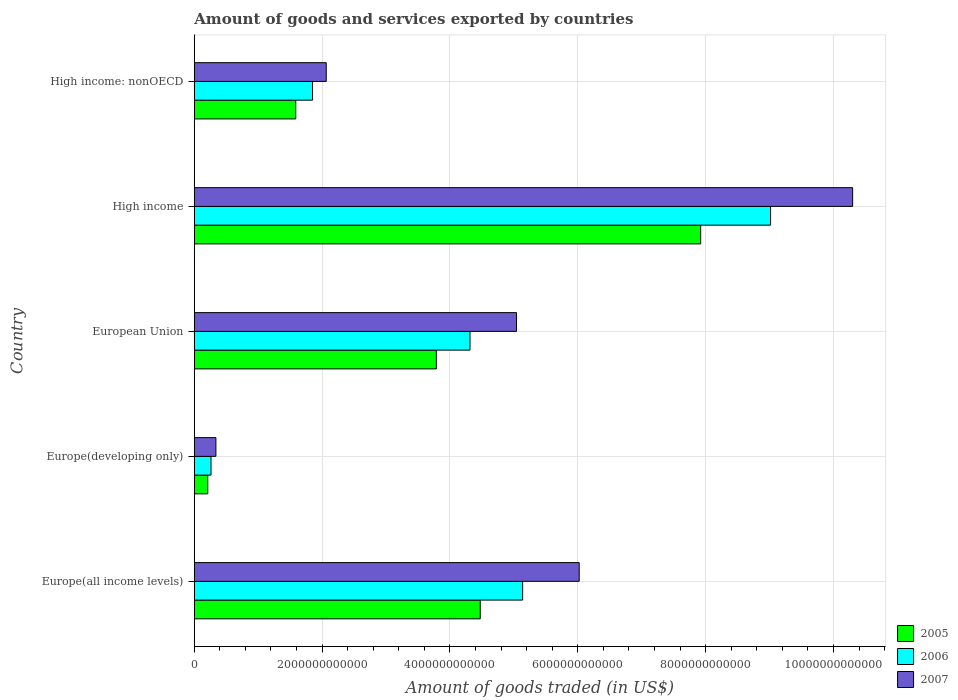How many different coloured bars are there?
Provide a succinct answer. 3. Are the number of bars per tick equal to the number of legend labels?
Give a very brief answer. Yes. Are the number of bars on each tick of the Y-axis equal?
Your answer should be compact. Yes. How many bars are there on the 4th tick from the top?
Make the answer very short. 3. How many bars are there on the 4th tick from the bottom?
Your response must be concise. 3. What is the label of the 4th group of bars from the top?
Keep it short and to the point. Europe(developing only). In how many cases, is the number of bars for a given country not equal to the number of legend labels?
Provide a succinct answer. 0. What is the total amount of goods and services exported in 2006 in High income?
Provide a succinct answer. 9.02e+12. Across all countries, what is the maximum total amount of goods and services exported in 2006?
Your answer should be very brief. 9.02e+12. Across all countries, what is the minimum total amount of goods and services exported in 2005?
Your answer should be very brief. 2.11e+11. In which country was the total amount of goods and services exported in 2006 minimum?
Make the answer very short. Europe(developing only). What is the total total amount of goods and services exported in 2007 in the graph?
Make the answer very short. 2.38e+13. What is the difference between the total amount of goods and services exported in 2006 in Europe(developing only) and that in High income: nonOECD?
Provide a short and direct response. -1.59e+12. What is the difference between the total amount of goods and services exported in 2007 in Europe(developing only) and the total amount of goods and services exported in 2006 in European Union?
Your answer should be very brief. -3.98e+12. What is the average total amount of goods and services exported in 2006 per country?
Your answer should be very brief. 4.12e+12. What is the difference between the total amount of goods and services exported in 2007 and total amount of goods and services exported in 2005 in Europe(developing only)?
Offer a very short reply. 1.28e+11. In how many countries, is the total amount of goods and services exported in 2007 greater than 8800000000000 US$?
Ensure brevity in your answer.  1. What is the ratio of the total amount of goods and services exported in 2005 in Europe(developing only) to that in High income?
Offer a terse response. 0.03. Is the total amount of goods and services exported in 2005 in Europe(all income levels) less than that in High income?
Your response must be concise. Yes. What is the difference between the highest and the second highest total amount of goods and services exported in 2007?
Give a very brief answer. 4.28e+12. What is the difference between the highest and the lowest total amount of goods and services exported in 2005?
Your answer should be compact. 7.71e+12. Is the sum of the total amount of goods and services exported in 2005 in European Union and High income greater than the maximum total amount of goods and services exported in 2006 across all countries?
Your answer should be very brief. Yes. What does the 2nd bar from the top in European Union represents?
Keep it short and to the point. 2006. What does the 2nd bar from the bottom in European Union represents?
Ensure brevity in your answer.  2006. How many countries are there in the graph?
Your answer should be very brief. 5. What is the difference between two consecutive major ticks on the X-axis?
Offer a very short reply. 2.00e+12. Are the values on the major ticks of X-axis written in scientific E-notation?
Your answer should be very brief. No. What is the title of the graph?
Give a very brief answer. Amount of goods and services exported by countries. What is the label or title of the X-axis?
Provide a short and direct response. Amount of goods traded (in US$). What is the label or title of the Y-axis?
Make the answer very short. Country. What is the Amount of goods traded (in US$) in 2005 in Europe(all income levels)?
Your response must be concise. 4.47e+12. What is the Amount of goods traded (in US$) of 2006 in Europe(all income levels)?
Your answer should be compact. 5.14e+12. What is the Amount of goods traded (in US$) of 2007 in Europe(all income levels)?
Your response must be concise. 6.02e+12. What is the Amount of goods traded (in US$) of 2005 in Europe(developing only)?
Ensure brevity in your answer.  2.11e+11. What is the Amount of goods traded (in US$) of 2006 in Europe(developing only)?
Keep it short and to the point. 2.62e+11. What is the Amount of goods traded (in US$) in 2007 in Europe(developing only)?
Your response must be concise. 3.39e+11. What is the Amount of goods traded (in US$) in 2005 in European Union?
Offer a terse response. 3.79e+12. What is the Amount of goods traded (in US$) in 2006 in European Union?
Provide a succinct answer. 4.31e+12. What is the Amount of goods traded (in US$) of 2007 in European Union?
Keep it short and to the point. 5.04e+12. What is the Amount of goods traded (in US$) of 2005 in High income?
Keep it short and to the point. 7.92e+12. What is the Amount of goods traded (in US$) in 2006 in High income?
Your answer should be compact. 9.02e+12. What is the Amount of goods traded (in US$) of 2007 in High income?
Your response must be concise. 1.03e+13. What is the Amount of goods traded (in US$) in 2005 in High income: nonOECD?
Keep it short and to the point. 1.59e+12. What is the Amount of goods traded (in US$) in 2006 in High income: nonOECD?
Your answer should be compact. 1.85e+12. What is the Amount of goods traded (in US$) in 2007 in High income: nonOECD?
Make the answer very short. 2.06e+12. Across all countries, what is the maximum Amount of goods traded (in US$) in 2005?
Provide a succinct answer. 7.92e+12. Across all countries, what is the maximum Amount of goods traded (in US$) in 2006?
Ensure brevity in your answer.  9.02e+12. Across all countries, what is the maximum Amount of goods traded (in US$) of 2007?
Your response must be concise. 1.03e+13. Across all countries, what is the minimum Amount of goods traded (in US$) in 2005?
Offer a terse response. 2.11e+11. Across all countries, what is the minimum Amount of goods traded (in US$) of 2006?
Keep it short and to the point. 2.62e+11. Across all countries, what is the minimum Amount of goods traded (in US$) in 2007?
Make the answer very short. 3.39e+11. What is the total Amount of goods traded (in US$) of 2005 in the graph?
Make the answer very short. 1.80e+13. What is the total Amount of goods traded (in US$) of 2006 in the graph?
Your response must be concise. 2.06e+13. What is the total Amount of goods traded (in US$) of 2007 in the graph?
Keep it short and to the point. 2.38e+13. What is the difference between the Amount of goods traded (in US$) of 2005 in Europe(all income levels) and that in Europe(developing only)?
Your answer should be compact. 4.26e+12. What is the difference between the Amount of goods traded (in US$) of 2006 in Europe(all income levels) and that in Europe(developing only)?
Your response must be concise. 4.88e+12. What is the difference between the Amount of goods traded (in US$) in 2007 in Europe(all income levels) and that in Europe(developing only)?
Your answer should be compact. 5.68e+12. What is the difference between the Amount of goods traded (in US$) of 2005 in Europe(all income levels) and that in European Union?
Make the answer very short. 6.86e+11. What is the difference between the Amount of goods traded (in US$) in 2006 in Europe(all income levels) and that in European Union?
Provide a short and direct response. 8.23e+11. What is the difference between the Amount of goods traded (in US$) in 2007 in Europe(all income levels) and that in European Union?
Keep it short and to the point. 9.81e+11. What is the difference between the Amount of goods traded (in US$) of 2005 in Europe(all income levels) and that in High income?
Ensure brevity in your answer.  -3.45e+12. What is the difference between the Amount of goods traded (in US$) of 2006 in Europe(all income levels) and that in High income?
Your answer should be compact. -3.88e+12. What is the difference between the Amount of goods traded (in US$) of 2007 in Europe(all income levels) and that in High income?
Offer a terse response. -4.28e+12. What is the difference between the Amount of goods traded (in US$) in 2005 in Europe(all income levels) and that in High income: nonOECD?
Offer a terse response. 2.89e+12. What is the difference between the Amount of goods traded (in US$) of 2006 in Europe(all income levels) and that in High income: nonOECD?
Your answer should be very brief. 3.29e+12. What is the difference between the Amount of goods traded (in US$) of 2007 in Europe(all income levels) and that in High income: nonOECD?
Keep it short and to the point. 3.96e+12. What is the difference between the Amount of goods traded (in US$) of 2005 in Europe(developing only) and that in European Union?
Your answer should be very brief. -3.58e+12. What is the difference between the Amount of goods traded (in US$) of 2006 in Europe(developing only) and that in European Union?
Provide a succinct answer. -4.05e+12. What is the difference between the Amount of goods traded (in US$) of 2007 in Europe(developing only) and that in European Union?
Make the answer very short. -4.70e+12. What is the difference between the Amount of goods traded (in US$) in 2005 in Europe(developing only) and that in High income?
Offer a terse response. -7.71e+12. What is the difference between the Amount of goods traded (in US$) of 2006 in Europe(developing only) and that in High income?
Offer a very short reply. -8.75e+12. What is the difference between the Amount of goods traded (in US$) of 2007 in Europe(developing only) and that in High income?
Make the answer very short. -9.96e+12. What is the difference between the Amount of goods traded (in US$) in 2005 in Europe(developing only) and that in High income: nonOECD?
Make the answer very short. -1.38e+12. What is the difference between the Amount of goods traded (in US$) in 2006 in Europe(developing only) and that in High income: nonOECD?
Offer a terse response. -1.59e+12. What is the difference between the Amount of goods traded (in US$) of 2007 in Europe(developing only) and that in High income: nonOECD?
Keep it short and to the point. -1.73e+12. What is the difference between the Amount of goods traded (in US$) of 2005 in European Union and that in High income?
Make the answer very short. -4.14e+12. What is the difference between the Amount of goods traded (in US$) of 2006 in European Union and that in High income?
Give a very brief answer. -4.70e+12. What is the difference between the Amount of goods traded (in US$) of 2007 in European Union and that in High income?
Provide a succinct answer. -5.26e+12. What is the difference between the Amount of goods traded (in US$) in 2005 in European Union and that in High income: nonOECD?
Your answer should be compact. 2.20e+12. What is the difference between the Amount of goods traded (in US$) of 2006 in European Union and that in High income: nonOECD?
Your answer should be compact. 2.46e+12. What is the difference between the Amount of goods traded (in US$) of 2007 in European Union and that in High income: nonOECD?
Provide a succinct answer. 2.98e+12. What is the difference between the Amount of goods traded (in US$) in 2005 in High income and that in High income: nonOECD?
Your response must be concise. 6.34e+12. What is the difference between the Amount of goods traded (in US$) of 2006 in High income and that in High income: nonOECD?
Your answer should be very brief. 7.17e+12. What is the difference between the Amount of goods traded (in US$) of 2007 in High income and that in High income: nonOECD?
Provide a succinct answer. 8.24e+12. What is the difference between the Amount of goods traded (in US$) of 2005 in Europe(all income levels) and the Amount of goods traded (in US$) of 2006 in Europe(developing only)?
Your answer should be very brief. 4.21e+12. What is the difference between the Amount of goods traded (in US$) of 2005 in Europe(all income levels) and the Amount of goods traded (in US$) of 2007 in Europe(developing only)?
Give a very brief answer. 4.14e+12. What is the difference between the Amount of goods traded (in US$) in 2006 in Europe(all income levels) and the Amount of goods traded (in US$) in 2007 in Europe(developing only)?
Your answer should be compact. 4.80e+12. What is the difference between the Amount of goods traded (in US$) of 2005 in Europe(all income levels) and the Amount of goods traded (in US$) of 2006 in European Union?
Your answer should be very brief. 1.60e+11. What is the difference between the Amount of goods traded (in US$) of 2005 in Europe(all income levels) and the Amount of goods traded (in US$) of 2007 in European Union?
Keep it short and to the point. -5.68e+11. What is the difference between the Amount of goods traded (in US$) in 2006 in Europe(all income levels) and the Amount of goods traded (in US$) in 2007 in European Union?
Offer a very short reply. 9.55e+1. What is the difference between the Amount of goods traded (in US$) in 2005 in Europe(all income levels) and the Amount of goods traded (in US$) in 2006 in High income?
Offer a very short reply. -4.54e+12. What is the difference between the Amount of goods traded (in US$) of 2005 in Europe(all income levels) and the Amount of goods traded (in US$) of 2007 in High income?
Offer a very short reply. -5.83e+12. What is the difference between the Amount of goods traded (in US$) of 2006 in Europe(all income levels) and the Amount of goods traded (in US$) of 2007 in High income?
Your answer should be very brief. -5.16e+12. What is the difference between the Amount of goods traded (in US$) in 2005 in Europe(all income levels) and the Amount of goods traded (in US$) in 2006 in High income: nonOECD?
Your answer should be very brief. 2.62e+12. What is the difference between the Amount of goods traded (in US$) in 2005 in Europe(all income levels) and the Amount of goods traded (in US$) in 2007 in High income: nonOECD?
Make the answer very short. 2.41e+12. What is the difference between the Amount of goods traded (in US$) in 2006 in Europe(all income levels) and the Amount of goods traded (in US$) in 2007 in High income: nonOECD?
Keep it short and to the point. 3.07e+12. What is the difference between the Amount of goods traded (in US$) of 2005 in Europe(developing only) and the Amount of goods traded (in US$) of 2006 in European Union?
Provide a succinct answer. -4.10e+12. What is the difference between the Amount of goods traded (in US$) of 2005 in Europe(developing only) and the Amount of goods traded (in US$) of 2007 in European Union?
Make the answer very short. -4.83e+12. What is the difference between the Amount of goods traded (in US$) of 2006 in Europe(developing only) and the Amount of goods traded (in US$) of 2007 in European Union?
Keep it short and to the point. -4.78e+12. What is the difference between the Amount of goods traded (in US$) in 2005 in Europe(developing only) and the Amount of goods traded (in US$) in 2006 in High income?
Give a very brief answer. -8.81e+12. What is the difference between the Amount of goods traded (in US$) in 2005 in Europe(developing only) and the Amount of goods traded (in US$) in 2007 in High income?
Offer a very short reply. -1.01e+13. What is the difference between the Amount of goods traded (in US$) in 2006 in Europe(developing only) and the Amount of goods traded (in US$) in 2007 in High income?
Your answer should be very brief. -1.00e+13. What is the difference between the Amount of goods traded (in US$) of 2005 in Europe(developing only) and the Amount of goods traded (in US$) of 2006 in High income: nonOECD?
Your answer should be compact. -1.64e+12. What is the difference between the Amount of goods traded (in US$) of 2005 in Europe(developing only) and the Amount of goods traded (in US$) of 2007 in High income: nonOECD?
Provide a succinct answer. -1.85e+12. What is the difference between the Amount of goods traded (in US$) of 2006 in Europe(developing only) and the Amount of goods traded (in US$) of 2007 in High income: nonOECD?
Your answer should be compact. -1.80e+12. What is the difference between the Amount of goods traded (in US$) of 2005 in European Union and the Amount of goods traded (in US$) of 2006 in High income?
Ensure brevity in your answer.  -5.23e+12. What is the difference between the Amount of goods traded (in US$) in 2005 in European Union and the Amount of goods traded (in US$) in 2007 in High income?
Give a very brief answer. -6.51e+12. What is the difference between the Amount of goods traded (in US$) of 2006 in European Union and the Amount of goods traded (in US$) of 2007 in High income?
Make the answer very short. -5.99e+12. What is the difference between the Amount of goods traded (in US$) of 2005 in European Union and the Amount of goods traded (in US$) of 2006 in High income: nonOECD?
Ensure brevity in your answer.  1.94e+12. What is the difference between the Amount of goods traded (in US$) in 2005 in European Union and the Amount of goods traded (in US$) in 2007 in High income: nonOECD?
Make the answer very short. 1.72e+12. What is the difference between the Amount of goods traded (in US$) of 2006 in European Union and the Amount of goods traded (in US$) of 2007 in High income: nonOECD?
Provide a short and direct response. 2.25e+12. What is the difference between the Amount of goods traded (in US$) in 2005 in High income and the Amount of goods traded (in US$) in 2006 in High income: nonOECD?
Your answer should be compact. 6.07e+12. What is the difference between the Amount of goods traded (in US$) in 2005 in High income and the Amount of goods traded (in US$) in 2007 in High income: nonOECD?
Offer a terse response. 5.86e+12. What is the difference between the Amount of goods traded (in US$) of 2006 in High income and the Amount of goods traded (in US$) of 2007 in High income: nonOECD?
Make the answer very short. 6.95e+12. What is the average Amount of goods traded (in US$) in 2005 per country?
Your response must be concise. 3.60e+12. What is the average Amount of goods traded (in US$) of 2006 per country?
Provide a succinct answer. 4.12e+12. What is the average Amount of goods traded (in US$) of 2007 per country?
Provide a succinct answer. 4.75e+12. What is the difference between the Amount of goods traded (in US$) of 2005 and Amount of goods traded (in US$) of 2006 in Europe(all income levels)?
Provide a succinct answer. -6.64e+11. What is the difference between the Amount of goods traded (in US$) of 2005 and Amount of goods traded (in US$) of 2007 in Europe(all income levels)?
Provide a succinct answer. -1.55e+12. What is the difference between the Amount of goods traded (in US$) of 2006 and Amount of goods traded (in US$) of 2007 in Europe(all income levels)?
Offer a terse response. -8.85e+11. What is the difference between the Amount of goods traded (in US$) in 2005 and Amount of goods traded (in US$) in 2006 in Europe(developing only)?
Your response must be concise. -5.09e+1. What is the difference between the Amount of goods traded (in US$) in 2005 and Amount of goods traded (in US$) in 2007 in Europe(developing only)?
Your answer should be compact. -1.28e+11. What is the difference between the Amount of goods traded (in US$) in 2006 and Amount of goods traded (in US$) in 2007 in Europe(developing only)?
Provide a succinct answer. -7.67e+1. What is the difference between the Amount of goods traded (in US$) of 2005 and Amount of goods traded (in US$) of 2006 in European Union?
Your answer should be compact. -5.26e+11. What is the difference between the Amount of goods traded (in US$) of 2005 and Amount of goods traded (in US$) of 2007 in European Union?
Your response must be concise. -1.25e+12. What is the difference between the Amount of goods traded (in US$) of 2006 and Amount of goods traded (in US$) of 2007 in European Union?
Offer a very short reply. -7.28e+11. What is the difference between the Amount of goods traded (in US$) in 2005 and Amount of goods traded (in US$) in 2006 in High income?
Offer a very short reply. -1.09e+12. What is the difference between the Amount of goods traded (in US$) of 2005 and Amount of goods traded (in US$) of 2007 in High income?
Make the answer very short. -2.38e+12. What is the difference between the Amount of goods traded (in US$) of 2006 and Amount of goods traded (in US$) of 2007 in High income?
Your answer should be compact. -1.28e+12. What is the difference between the Amount of goods traded (in US$) in 2005 and Amount of goods traded (in US$) in 2006 in High income: nonOECD?
Provide a succinct answer. -2.63e+11. What is the difference between the Amount of goods traded (in US$) in 2005 and Amount of goods traded (in US$) in 2007 in High income: nonOECD?
Ensure brevity in your answer.  -4.77e+11. What is the difference between the Amount of goods traded (in US$) of 2006 and Amount of goods traded (in US$) of 2007 in High income: nonOECD?
Provide a succinct answer. -2.14e+11. What is the ratio of the Amount of goods traded (in US$) of 2005 in Europe(all income levels) to that in Europe(developing only)?
Keep it short and to the point. 21.19. What is the ratio of the Amount of goods traded (in US$) in 2006 in Europe(all income levels) to that in Europe(developing only)?
Offer a very short reply. 19.61. What is the ratio of the Amount of goods traded (in US$) of 2007 in Europe(all income levels) to that in Europe(developing only)?
Your answer should be very brief. 17.78. What is the ratio of the Amount of goods traded (in US$) of 2005 in Europe(all income levels) to that in European Union?
Your answer should be compact. 1.18. What is the ratio of the Amount of goods traded (in US$) in 2006 in Europe(all income levels) to that in European Union?
Your response must be concise. 1.19. What is the ratio of the Amount of goods traded (in US$) in 2007 in Europe(all income levels) to that in European Union?
Provide a succinct answer. 1.19. What is the ratio of the Amount of goods traded (in US$) in 2005 in Europe(all income levels) to that in High income?
Your answer should be very brief. 0.56. What is the ratio of the Amount of goods traded (in US$) of 2006 in Europe(all income levels) to that in High income?
Offer a very short reply. 0.57. What is the ratio of the Amount of goods traded (in US$) in 2007 in Europe(all income levels) to that in High income?
Provide a short and direct response. 0.58. What is the ratio of the Amount of goods traded (in US$) in 2005 in Europe(all income levels) to that in High income: nonOECD?
Offer a terse response. 2.82. What is the ratio of the Amount of goods traded (in US$) in 2006 in Europe(all income levels) to that in High income: nonOECD?
Your response must be concise. 2.78. What is the ratio of the Amount of goods traded (in US$) of 2007 in Europe(all income levels) to that in High income: nonOECD?
Your answer should be compact. 2.92. What is the ratio of the Amount of goods traded (in US$) of 2005 in Europe(developing only) to that in European Union?
Your answer should be very brief. 0.06. What is the ratio of the Amount of goods traded (in US$) of 2006 in Europe(developing only) to that in European Union?
Make the answer very short. 0.06. What is the ratio of the Amount of goods traded (in US$) of 2007 in Europe(developing only) to that in European Union?
Your response must be concise. 0.07. What is the ratio of the Amount of goods traded (in US$) in 2005 in Europe(developing only) to that in High income?
Your answer should be very brief. 0.03. What is the ratio of the Amount of goods traded (in US$) of 2006 in Europe(developing only) to that in High income?
Your response must be concise. 0.03. What is the ratio of the Amount of goods traded (in US$) of 2007 in Europe(developing only) to that in High income?
Keep it short and to the point. 0.03. What is the ratio of the Amount of goods traded (in US$) of 2005 in Europe(developing only) to that in High income: nonOECD?
Your response must be concise. 0.13. What is the ratio of the Amount of goods traded (in US$) in 2006 in Europe(developing only) to that in High income: nonOECD?
Offer a terse response. 0.14. What is the ratio of the Amount of goods traded (in US$) of 2007 in Europe(developing only) to that in High income: nonOECD?
Offer a very short reply. 0.16. What is the ratio of the Amount of goods traded (in US$) in 2005 in European Union to that in High income?
Provide a succinct answer. 0.48. What is the ratio of the Amount of goods traded (in US$) of 2006 in European Union to that in High income?
Provide a short and direct response. 0.48. What is the ratio of the Amount of goods traded (in US$) in 2007 in European Union to that in High income?
Make the answer very short. 0.49. What is the ratio of the Amount of goods traded (in US$) of 2005 in European Union to that in High income: nonOECD?
Make the answer very short. 2.39. What is the ratio of the Amount of goods traded (in US$) of 2006 in European Union to that in High income: nonOECD?
Your answer should be compact. 2.33. What is the ratio of the Amount of goods traded (in US$) in 2007 in European Union to that in High income: nonOECD?
Ensure brevity in your answer.  2.44. What is the ratio of the Amount of goods traded (in US$) of 2005 in High income to that in High income: nonOECD?
Offer a terse response. 4.99. What is the ratio of the Amount of goods traded (in US$) of 2006 in High income to that in High income: nonOECD?
Keep it short and to the point. 4.87. What is the ratio of the Amount of goods traded (in US$) of 2007 in High income to that in High income: nonOECD?
Offer a terse response. 4.99. What is the difference between the highest and the second highest Amount of goods traded (in US$) of 2005?
Your answer should be compact. 3.45e+12. What is the difference between the highest and the second highest Amount of goods traded (in US$) in 2006?
Keep it short and to the point. 3.88e+12. What is the difference between the highest and the second highest Amount of goods traded (in US$) of 2007?
Keep it short and to the point. 4.28e+12. What is the difference between the highest and the lowest Amount of goods traded (in US$) of 2005?
Provide a succinct answer. 7.71e+12. What is the difference between the highest and the lowest Amount of goods traded (in US$) in 2006?
Provide a short and direct response. 8.75e+12. What is the difference between the highest and the lowest Amount of goods traded (in US$) in 2007?
Your answer should be compact. 9.96e+12. 